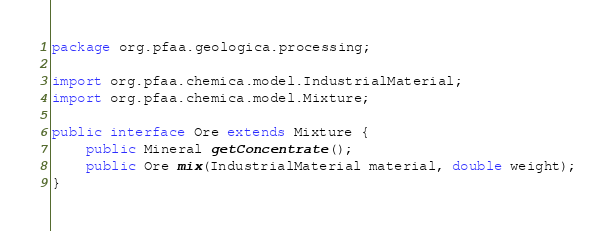Convert code to text. <code><loc_0><loc_0><loc_500><loc_500><_Java_>package org.pfaa.geologica.processing;

import org.pfaa.chemica.model.IndustrialMaterial;
import org.pfaa.chemica.model.Mixture;

public interface Ore extends Mixture {
	public Mineral getConcentrate();
	public Ore mix(IndustrialMaterial material, double weight);
}
</code> 